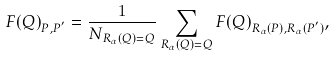Convert formula to latex. <formula><loc_0><loc_0><loc_500><loc_500>F ( Q ) _ { P , P ^ { ^ { \prime } } } = \frac { 1 } { N _ { R _ { \alpha } ( Q ) = Q } } \sum _ { R _ { \alpha } ( Q ) = Q } F ( Q ) _ { R _ { \alpha } ( P ) , R _ { \alpha } ( P ^ { ^ { \prime } } ) } ,</formula> 